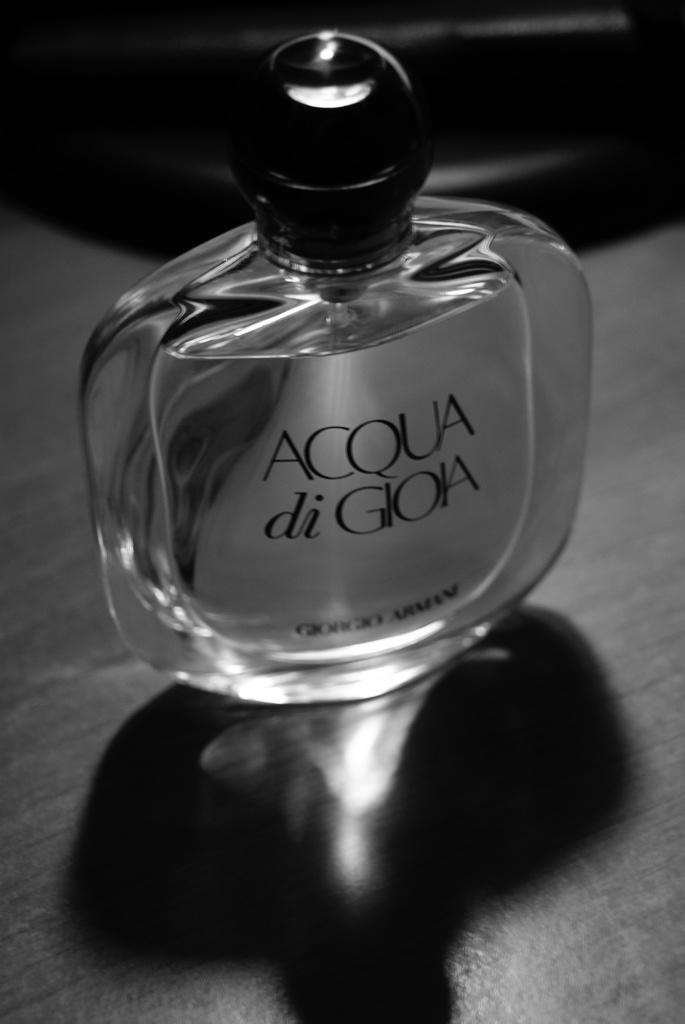What is this perfume called?
Make the answer very short. Acqua di gioia. 